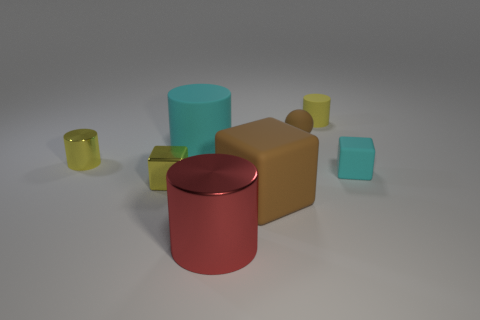There is a yellow matte object that is the same shape as the red metallic object; what size is it?
Give a very brief answer. Small. What is the shape of the small object that is both on the right side of the tiny matte sphere and in front of the matte sphere?
Keep it short and to the point. Cube. Is there anything else that is the same size as the red cylinder?
Your answer should be very brief. Yes. The small cylinder that is on the left side of the tiny yellow cylinder behind the small brown sphere is what color?
Provide a short and direct response. Yellow. There is a brown matte object that is in front of the small metallic thing to the right of the tiny cylinder that is left of the tiny yellow matte thing; what shape is it?
Provide a short and direct response. Cube. How big is the yellow object that is on the right side of the small yellow shiny cylinder and behind the small cyan matte thing?
Your answer should be compact. Small. How many small objects are the same color as the big rubber block?
Ensure brevity in your answer.  1. What is the material of the large cube that is the same color as the ball?
Provide a succinct answer. Rubber. What material is the tiny brown object?
Keep it short and to the point. Rubber. Is the cyan thing on the right side of the red cylinder made of the same material as the big cyan object?
Your response must be concise. Yes. 